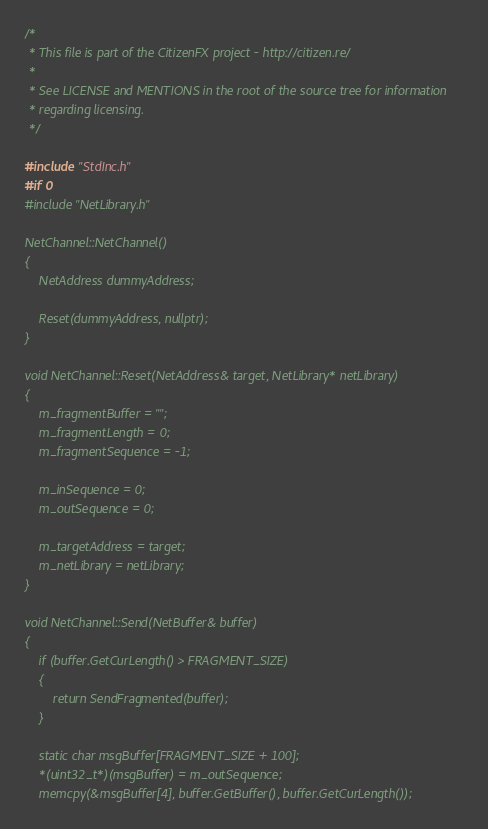<code> <loc_0><loc_0><loc_500><loc_500><_C++_>/*
 * This file is part of the CitizenFX project - http://citizen.re/
 *
 * See LICENSE and MENTIONS in the root of the source tree for information
 * regarding licensing.
 */

#include "StdInc.h"
#if 0
#include "NetLibrary.h"

NetChannel::NetChannel()
{
	NetAddress dummyAddress;

	Reset(dummyAddress, nullptr);
}

void NetChannel::Reset(NetAddress& target, NetLibrary* netLibrary)
{
	m_fragmentBuffer = "";
	m_fragmentLength = 0;
	m_fragmentSequence = -1;
	
	m_inSequence = 0;
	m_outSequence = 0;

	m_targetAddress = target;
	m_netLibrary = netLibrary;
}

void NetChannel::Send(NetBuffer& buffer)
{
	if (buffer.GetCurLength() > FRAGMENT_SIZE)
	{
		return SendFragmented(buffer);
	}

	static char msgBuffer[FRAGMENT_SIZE + 100];
	*(uint32_t*)(msgBuffer) = m_outSequence;
	memcpy(&msgBuffer[4], buffer.GetBuffer(), buffer.GetCurLength());
</code> 